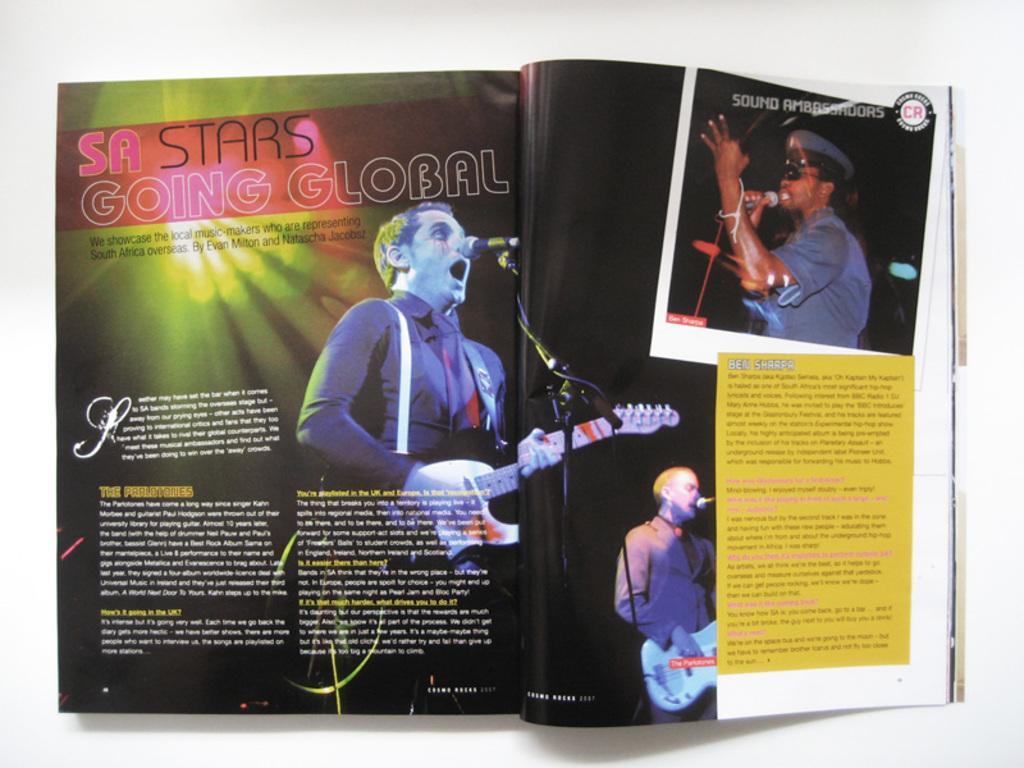Can you describe this image briefly? In this picture we can see a book on the white surface and in this book we can see three people, mics, guitars and some text. 